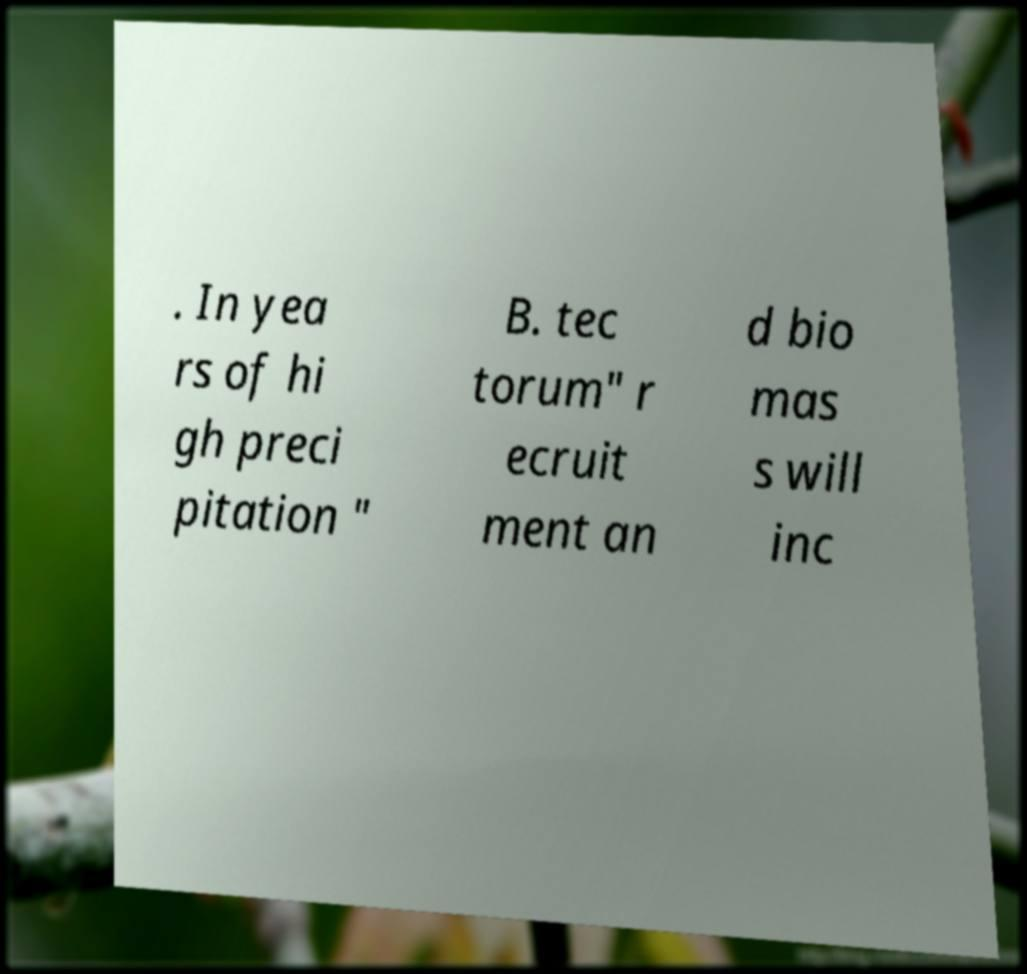Can you read and provide the text displayed in the image?This photo seems to have some interesting text. Can you extract and type it out for me? . In yea rs of hi gh preci pitation " B. tec torum" r ecruit ment an d bio mas s will inc 